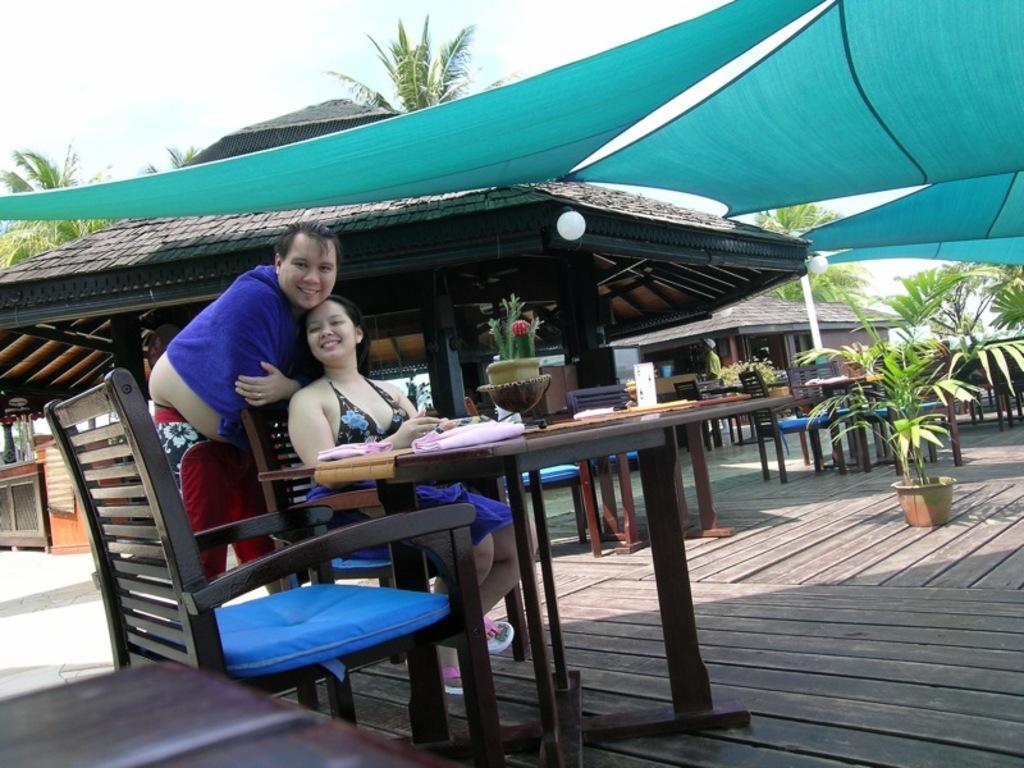In one or two sentences, can you explain what this image depicts? In the image we can see two persons the lady she is sitting on the chair around the table. On table we can see some objects. And coming to the background we can see some house,sky with clouds,trees and sheet and plant pot,some more tables,chairs etc. And in front we can see two persons were smiling. 